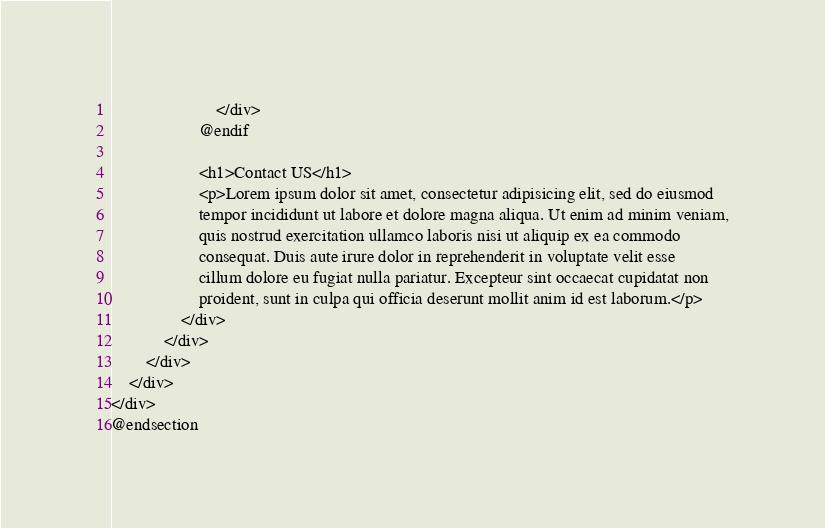Convert code to text. <code><loc_0><loc_0><loc_500><loc_500><_PHP_>                        </div>
                    @endif

                    <h1>Contact US</h1>
                    <p>Lorem ipsum dolor sit amet, consectetur adipisicing elit, sed do eiusmod
                    tempor incididunt ut labore et dolore magna aliqua. Ut enim ad minim veniam,
                    quis nostrud exercitation ullamco laboris nisi ut aliquip ex ea commodo
                    consequat. Duis aute irure dolor in reprehenderit in voluptate velit esse
                    cillum dolore eu fugiat nulla pariatur. Excepteur sint occaecat cupidatat non
                    proident, sunt in culpa qui officia deserunt mollit anim id est laborum.</p>
                </div>
            </div>
        </div>
    </div>
</div>
@endsection
</code> 